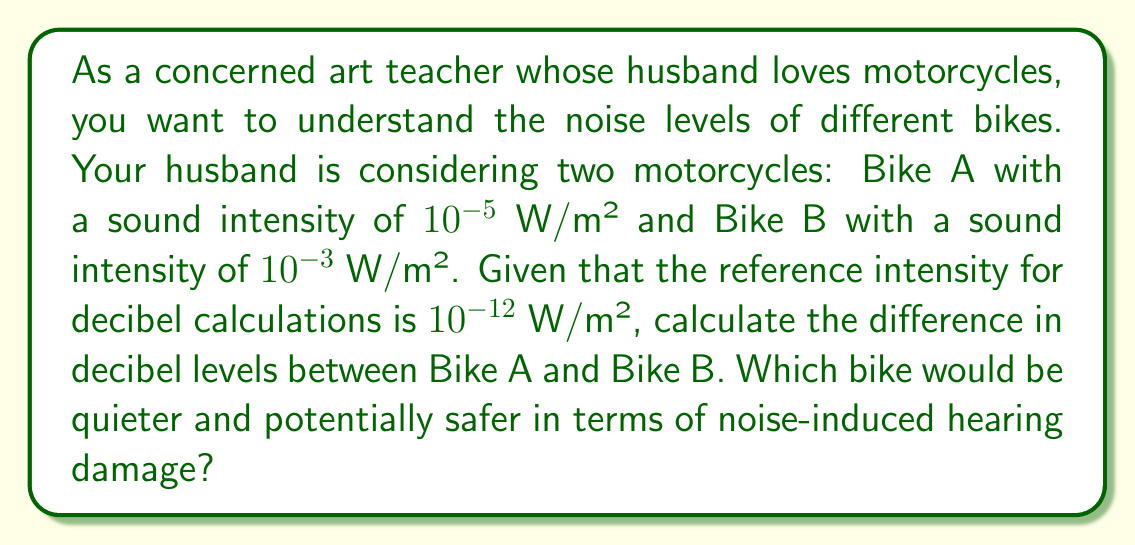Can you answer this question? To solve this problem, we'll use the formula for sound intensity level in decibels:

$$ \beta = 10 \log_{10}\left(\frac{I}{I_0}\right) $$

Where:
$\beta$ is the sound intensity level in decibels (dB)
$I$ is the sound intensity of the source
$I_0$ is the reference intensity ($10^{-12}$ W/m²)

Step 1: Calculate the decibel level for Bike A
$$ \beta_A = 10 \log_{10}\left(\frac{10^{-5}}{10^{-12}}\right) = 10 \log_{10}(10^7) = 10 \cdot 7 = 70 \text{ dB} $$

Step 2: Calculate the decibel level for Bike B
$$ \beta_B = 10 \log_{10}\left(\frac{10^{-3}}{10^{-12}}\right) = 10 \log_{10}(10^9) = 10 \cdot 9 = 90 \text{ dB} $$

Step 3: Calculate the difference in decibel levels
$$ \Delta \beta = \beta_B - \beta_A = 90 \text{ dB} - 70 \text{ dB} = 20 \text{ dB} $$

Bike A is quieter, with a sound intensity level 20 dB lower than Bike B. This represents a significant difference in perceived loudness and potential for hearing damage. Generally, prolonged exposure to sounds above 85 dB can cause hearing damage, so Bike A would be the safer choice in terms of noise-induced hearing risks.
Answer: The difference in decibel levels between Bike A and Bike B is 20 dB. Bike A is quieter and potentially safer in terms of noise-induced hearing damage. 